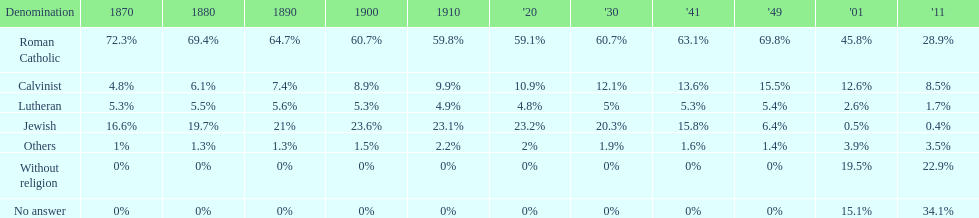Which religious group had the highest proportion in 1880? Roman Catholic. 